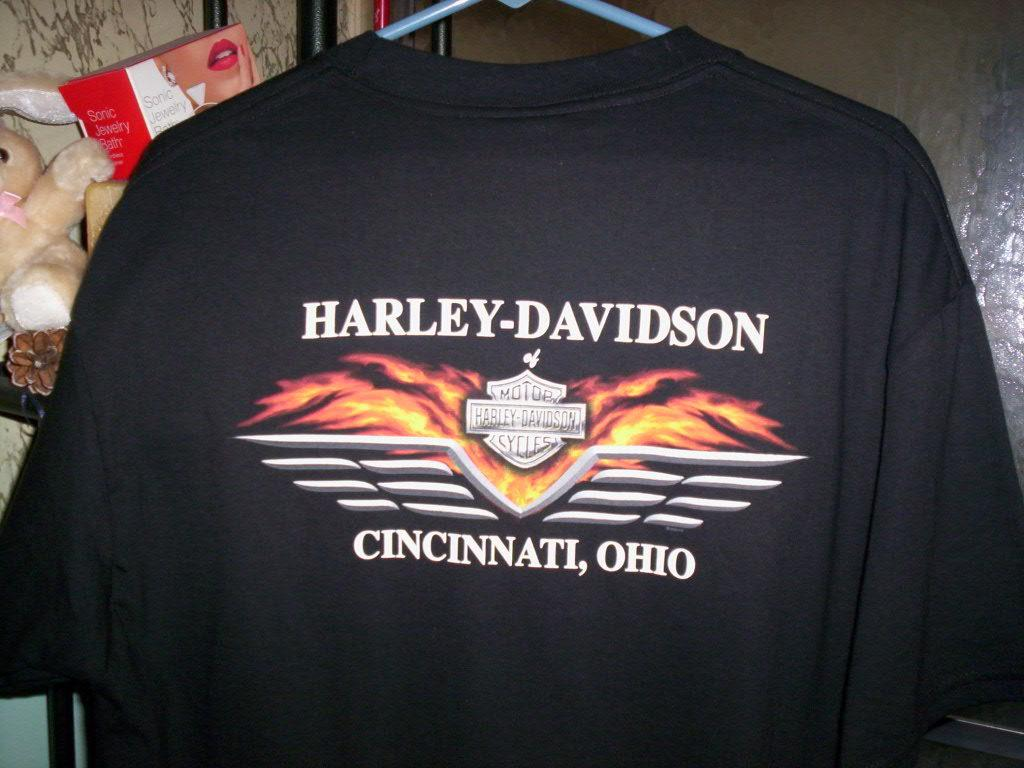<image>
Describe the image concisely. A Harley-Davidson shirt is hung on a hanger. 